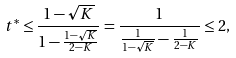<formula> <loc_0><loc_0><loc_500><loc_500>t ^ { * } \leq \frac { 1 - \sqrt { K } } { 1 - \frac { 1 - \sqrt { K } } { 2 - K } } = \frac { 1 } { \frac { 1 } { 1 - \sqrt { K } } - \frac { 1 } { 2 - K } } \leq 2 ,</formula> 